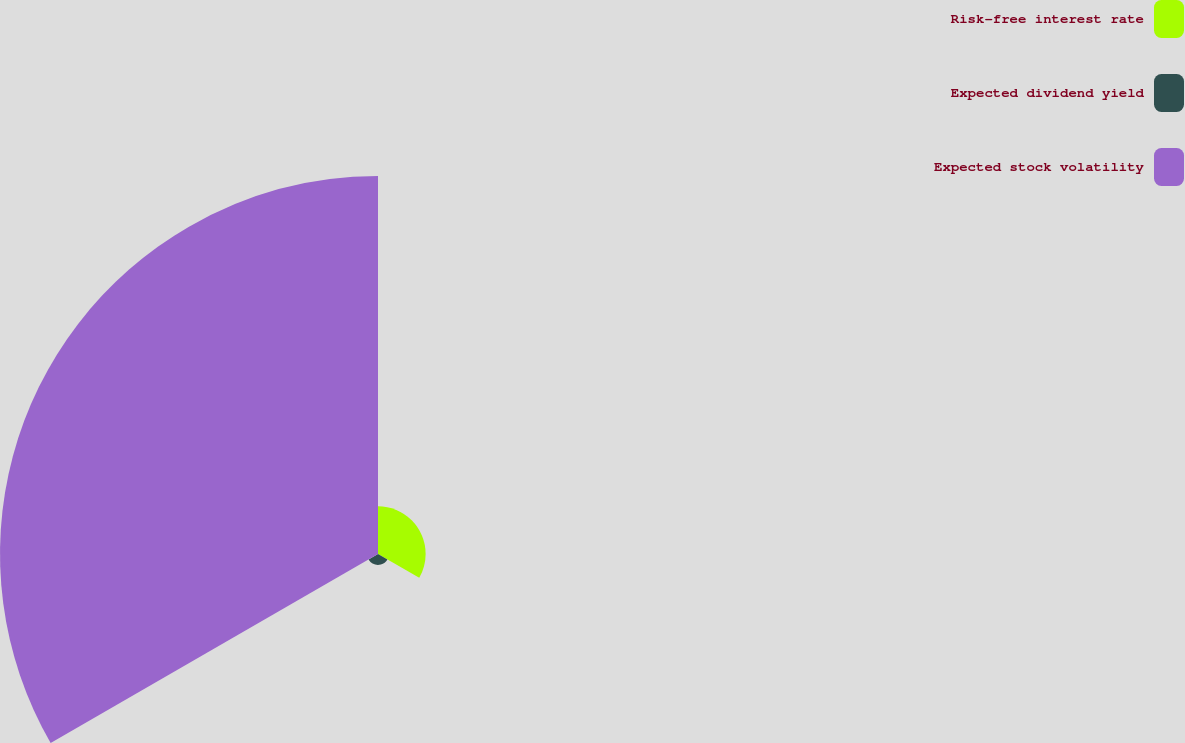<chart> <loc_0><loc_0><loc_500><loc_500><pie_chart><fcel>Risk-free interest rate<fcel>Expected dividend yield<fcel>Expected stock volatility<nl><fcel>10.91%<fcel>2.5%<fcel>86.59%<nl></chart> 